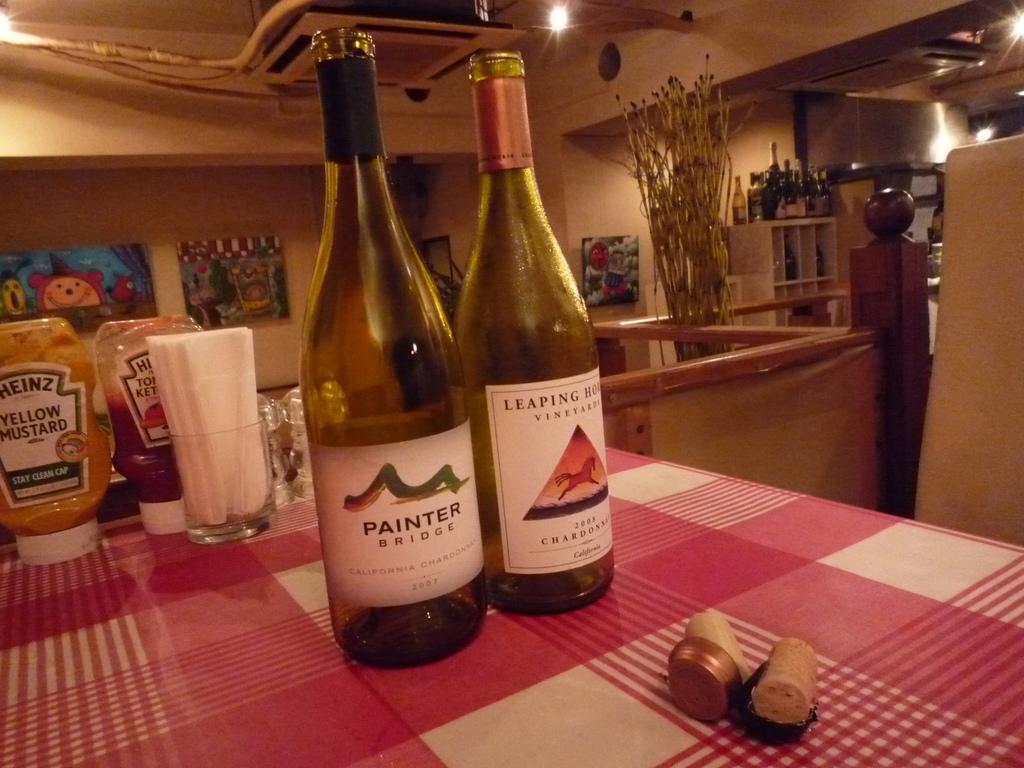What kind of wine is this?
Provide a short and direct response. Painter. 